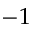<formula> <loc_0><loc_0><loc_500><loc_500>- 1</formula> 